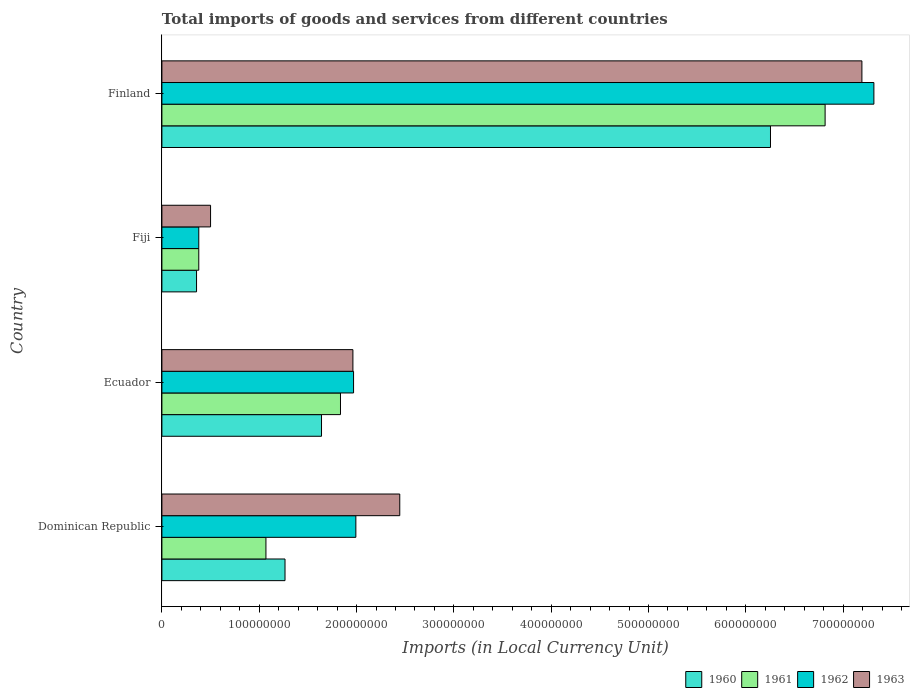How many different coloured bars are there?
Make the answer very short. 4. How many bars are there on the 1st tick from the top?
Give a very brief answer. 4. How many bars are there on the 4th tick from the bottom?
Offer a terse response. 4. What is the label of the 2nd group of bars from the top?
Give a very brief answer. Fiji. In how many cases, is the number of bars for a given country not equal to the number of legend labels?
Provide a succinct answer. 0. What is the Amount of goods and services imports in 1962 in Ecuador?
Keep it short and to the point. 1.97e+08. Across all countries, what is the maximum Amount of goods and services imports in 1963?
Your answer should be compact. 7.19e+08. Across all countries, what is the minimum Amount of goods and services imports in 1963?
Keep it short and to the point. 5.00e+07. In which country was the Amount of goods and services imports in 1961 maximum?
Your answer should be very brief. Finland. In which country was the Amount of goods and services imports in 1961 minimum?
Keep it short and to the point. Fiji. What is the total Amount of goods and services imports in 1963 in the graph?
Offer a very short reply. 1.21e+09. What is the difference between the Amount of goods and services imports in 1963 in Dominican Republic and that in Fiji?
Offer a very short reply. 1.94e+08. What is the difference between the Amount of goods and services imports in 1961 in Ecuador and the Amount of goods and services imports in 1960 in Finland?
Your response must be concise. -4.42e+08. What is the average Amount of goods and services imports in 1960 per country?
Offer a terse response. 2.38e+08. What is the difference between the Amount of goods and services imports in 1960 and Amount of goods and services imports in 1961 in Fiji?
Your response must be concise. -2.30e+06. In how many countries, is the Amount of goods and services imports in 1962 greater than 480000000 LCU?
Offer a terse response. 1. What is the ratio of the Amount of goods and services imports in 1962 in Dominican Republic to that in Finland?
Your response must be concise. 0.27. Is the Amount of goods and services imports in 1960 in Dominican Republic less than that in Fiji?
Offer a very short reply. No. What is the difference between the highest and the second highest Amount of goods and services imports in 1962?
Ensure brevity in your answer.  5.32e+08. What is the difference between the highest and the lowest Amount of goods and services imports in 1963?
Offer a terse response. 6.69e+08. In how many countries, is the Amount of goods and services imports in 1962 greater than the average Amount of goods and services imports in 1962 taken over all countries?
Keep it short and to the point. 1. What does the 4th bar from the bottom in Dominican Republic represents?
Keep it short and to the point. 1963. Are all the bars in the graph horizontal?
Keep it short and to the point. Yes. How many countries are there in the graph?
Ensure brevity in your answer.  4. Are the values on the major ticks of X-axis written in scientific E-notation?
Provide a succinct answer. No. Does the graph contain grids?
Provide a short and direct response. No. Where does the legend appear in the graph?
Your answer should be very brief. Bottom right. What is the title of the graph?
Your response must be concise. Total imports of goods and services from different countries. Does "2007" appear as one of the legend labels in the graph?
Your answer should be very brief. No. What is the label or title of the X-axis?
Provide a short and direct response. Imports (in Local Currency Unit). What is the Imports (in Local Currency Unit) of 1960 in Dominican Republic?
Your response must be concise. 1.26e+08. What is the Imports (in Local Currency Unit) in 1961 in Dominican Republic?
Provide a succinct answer. 1.07e+08. What is the Imports (in Local Currency Unit) in 1962 in Dominican Republic?
Your answer should be very brief. 1.99e+08. What is the Imports (in Local Currency Unit) in 1963 in Dominican Republic?
Provide a succinct answer. 2.44e+08. What is the Imports (in Local Currency Unit) of 1960 in Ecuador?
Your answer should be compact. 1.64e+08. What is the Imports (in Local Currency Unit) in 1961 in Ecuador?
Give a very brief answer. 1.83e+08. What is the Imports (in Local Currency Unit) in 1962 in Ecuador?
Provide a succinct answer. 1.97e+08. What is the Imports (in Local Currency Unit) of 1963 in Ecuador?
Make the answer very short. 1.96e+08. What is the Imports (in Local Currency Unit) in 1960 in Fiji?
Give a very brief answer. 3.56e+07. What is the Imports (in Local Currency Unit) of 1961 in Fiji?
Provide a succinct answer. 3.79e+07. What is the Imports (in Local Currency Unit) in 1962 in Fiji?
Make the answer very short. 3.79e+07. What is the Imports (in Local Currency Unit) of 1960 in Finland?
Your response must be concise. 6.25e+08. What is the Imports (in Local Currency Unit) in 1961 in Finland?
Give a very brief answer. 6.81e+08. What is the Imports (in Local Currency Unit) of 1962 in Finland?
Keep it short and to the point. 7.32e+08. What is the Imports (in Local Currency Unit) of 1963 in Finland?
Offer a terse response. 7.19e+08. Across all countries, what is the maximum Imports (in Local Currency Unit) in 1960?
Make the answer very short. 6.25e+08. Across all countries, what is the maximum Imports (in Local Currency Unit) in 1961?
Give a very brief answer. 6.81e+08. Across all countries, what is the maximum Imports (in Local Currency Unit) in 1962?
Your answer should be compact. 7.32e+08. Across all countries, what is the maximum Imports (in Local Currency Unit) of 1963?
Ensure brevity in your answer.  7.19e+08. Across all countries, what is the minimum Imports (in Local Currency Unit) of 1960?
Provide a short and direct response. 3.56e+07. Across all countries, what is the minimum Imports (in Local Currency Unit) in 1961?
Offer a terse response. 3.79e+07. Across all countries, what is the minimum Imports (in Local Currency Unit) in 1962?
Your answer should be very brief. 3.79e+07. What is the total Imports (in Local Currency Unit) in 1960 in the graph?
Your answer should be compact. 9.51e+08. What is the total Imports (in Local Currency Unit) in 1961 in the graph?
Offer a very short reply. 1.01e+09. What is the total Imports (in Local Currency Unit) of 1962 in the graph?
Provide a short and direct response. 1.17e+09. What is the total Imports (in Local Currency Unit) in 1963 in the graph?
Make the answer very short. 1.21e+09. What is the difference between the Imports (in Local Currency Unit) of 1960 in Dominican Republic and that in Ecuador?
Your answer should be very brief. -3.75e+07. What is the difference between the Imports (in Local Currency Unit) in 1961 in Dominican Republic and that in Ecuador?
Offer a very short reply. -7.66e+07. What is the difference between the Imports (in Local Currency Unit) of 1962 in Dominican Republic and that in Ecuador?
Your answer should be compact. 2.37e+06. What is the difference between the Imports (in Local Currency Unit) of 1963 in Dominican Republic and that in Ecuador?
Offer a terse response. 4.81e+07. What is the difference between the Imports (in Local Currency Unit) of 1960 in Dominican Republic and that in Fiji?
Keep it short and to the point. 9.09e+07. What is the difference between the Imports (in Local Currency Unit) in 1961 in Dominican Republic and that in Fiji?
Your answer should be very brief. 6.90e+07. What is the difference between the Imports (in Local Currency Unit) in 1962 in Dominican Republic and that in Fiji?
Your answer should be compact. 1.61e+08. What is the difference between the Imports (in Local Currency Unit) in 1963 in Dominican Republic and that in Fiji?
Keep it short and to the point. 1.94e+08. What is the difference between the Imports (in Local Currency Unit) of 1960 in Dominican Republic and that in Finland?
Make the answer very short. -4.99e+08. What is the difference between the Imports (in Local Currency Unit) in 1961 in Dominican Republic and that in Finland?
Offer a terse response. -5.75e+08. What is the difference between the Imports (in Local Currency Unit) in 1962 in Dominican Republic and that in Finland?
Give a very brief answer. -5.32e+08. What is the difference between the Imports (in Local Currency Unit) of 1963 in Dominican Republic and that in Finland?
Give a very brief answer. -4.75e+08. What is the difference between the Imports (in Local Currency Unit) of 1960 in Ecuador and that in Fiji?
Your response must be concise. 1.28e+08. What is the difference between the Imports (in Local Currency Unit) of 1961 in Ecuador and that in Fiji?
Ensure brevity in your answer.  1.46e+08. What is the difference between the Imports (in Local Currency Unit) of 1962 in Ecuador and that in Fiji?
Offer a terse response. 1.59e+08. What is the difference between the Imports (in Local Currency Unit) in 1963 in Ecuador and that in Fiji?
Give a very brief answer. 1.46e+08. What is the difference between the Imports (in Local Currency Unit) of 1960 in Ecuador and that in Finland?
Provide a short and direct response. -4.61e+08. What is the difference between the Imports (in Local Currency Unit) in 1961 in Ecuador and that in Finland?
Give a very brief answer. -4.98e+08. What is the difference between the Imports (in Local Currency Unit) in 1962 in Ecuador and that in Finland?
Give a very brief answer. -5.35e+08. What is the difference between the Imports (in Local Currency Unit) of 1963 in Ecuador and that in Finland?
Your answer should be very brief. -5.23e+08. What is the difference between the Imports (in Local Currency Unit) in 1960 in Fiji and that in Finland?
Provide a succinct answer. -5.90e+08. What is the difference between the Imports (in Local Currency Unit) in 1961 in Fiji and that in Finland?
Your answer should be very brief. -6.44e+08. What is the difference between the Imports (in Local Currency Unit) in 1962 in Fiji and that in Finland?
Your answer should be very brief. -6.94e+08. What is the difference between the Imports (in Local Currency Unit) in 1963 in Fiji and that in Finland?
Your response must be concise. -6.69e+08. What is the difference between the Imports (in Local Currency Unit) of 1960 in Dominican Republic and the Imports (in Local Currency Unit) of 1961 in Ecuador?
Your answer should be compact. -5.70e+07. What is the difference between the Imports (in Local Currency Unit) in 1960 in Dominican Republic and the Imports (in Local Currency Unit) in 1962 in Ecuador?
Keep it short and to the point. -7.04e+07. What is the difference between the Imports (in Local Currency Unit) in 1960 in Dominican Republic and the Imports (in Local Currency Unit) in 1963 in Ecuador?
Make the answer very short. -6.98e+07. What is the difference between the Imports (in Local Currency Unit) of 1961 in Dominican Republic and the Imports (in Local Currency Unit) of 1962 in Ecuador?
Your answer should be compact. -9.00e+07. What is the difference between the Imports (in Local Currency Unit) of 1961 in Dominican Republic and the Imports (in Local Currency Unit) of 1963 in Ecuador?
Offer a terse response. -8.94e+07. What is the difference between the Imports (in Local Currency Unit) in 1962 in Dominican Republic and the Imports (in Local Currency Unit) in 1963 in Ecuador?
Give a very brief answer. 3.04e+06. What is the difference between the Imports (in Local Currency Unit) of 1960 in Dominican Republic and the Imports (in Local Currency Unit) of 1961 in Fiji?
Ensure brevity in your answer.  8.86e+07. What is the difference between the Imports (in Local Currency Unit) of 1960 in Dominican Republic and the Imports (in Local Currency Unit) of 1962 in Fiji?
Give a very brief answer. 8.86e+07. What is the difference between the Imports (in Local Currency Unit) in 1960 in Dominican Republic and the Imports (in Local Currency Unit) in 1963 in Fiji?
Provide a short and direct response. 7.65e+07. What is the difference between the Imports (in Local Currency Unit) in 1961 in Dominican Republic and the Imports (in Local Currency Unit) in 1962 in Fiji?
Offer a very short reply. 6.90e+07. What is the difference between the Imports (in Local Currency Unit) in 1961 in Dominican Republic and the Imports (in Local Currency Unit) in 1963 in Fiji?
Give a very brief answer. 5.69e+07. What is the difference between the Imports (in Local Currency Unit) in 1962 in Dominican Republic and the Imports (in Local Currency Unit) in 1963 in Fiji?
Provide a short and direct response. 1.49e+08. What is the difference between the Imports (in Local Currency Unit) in 1960 in Dominican Republic and the Imports (in Local Currency Unit) in 1961 in Finland?
Keep it short and to the point. -5.55e+08. What is the difference between the Imports (in Local Currency Unit) in 1960 in Dominican Republic and the Imports (in Local Currency Unit) in 1962 in Finland?
Keep it short and to the point. -6.05e+08. What is the difference between the Imports (in Local Currency Unit) of 1960 in Dominican Republic and the Imports (in Local Currency Unit) of 1963 in Finland?
Give a very brief answer. -5.93e+08. What is the difference between the Imports (in Local Currency Unit) of 1961 in Dominican Republic and the Imports (in Local Currency Unit) of 1962 in Finland?
Make the answer very short. -6.25e+08. What is the difference between the Imports (in Local Currency Unit) of 1961 in Dominican Republic and the Imports (in Local Currency Unit) of 1963 in Finland?
Offer a very short reply. -6.12e+08. What is the difference between the Imports (in Local Currency Unit) of 1962 in Dominican Republic and the Imports (in Local Currency Unit) of 1963 in Finland?
Your response must be concise. -5.20e+08. What is the difference between the Imports (in Local Currency Unit) of 1960 in Ecuador and the Imports (in Local Currency Unit) of 1961 in Fiji?
Keep it short and to the point. 1.26e+08. What is the difference between the Imports (in Local Currency Unit) of 1960 in Ecuador and the Imports (in Local Currency Unit) of 1962 in Fiji?
Give a very brief answer. 1.26e+08. What is the difference between the Imports (in Local Currency Unit) in 1960 in Ecuador and the Imports (in Local Currency Unit) in 1963 in Fiji?
Offer a terse response. 1.14e+08. What is the difference between the Imports (in Local Currency Unit) in 1961 in Ecuador and the Imports (in Local Currency Unit) in 1962 in Fiji?
Your answer should be very brief. 1.46e+08. What is the difference between the Imports (in Local Currency Unit) of 1961 in Ecuador and the Imports (in Local Currency Unit) of 1963 in Fiji?
Ensure brevity in your answer.  1.33e+08. What is the difference between the Imports (in Local Currency Unit) in 1962 in Ecuador and the Imports (in Local Currency Unit) in 1963 in Fiji?
Ensure brevity in your answer.  1.47e+08. What is the difference between the Imports (in Local Currency Unit) of 1960 in Ecuador and the Imports (in Local Currency Unit) of 1961 in Finland?
Provide a succinct answer. -5.17e+08. What is the difference between the Imports (in Local Currency Unit) of 1960 in Ecuador and the Imports (in Local Currency Unit) of 1962 in Finland?
Provide a succinct answer. -5.68e+08. What is the difference between the Imports (in Local Currency Unit) of 1960 in Ecuador and the Imports (in Local Currency Unit) of 1963 in Finland?
Keep it short and to the point. -5.55e+08. What is the difference between the Imports (in Local Currency Unit) of 1961 in Ecuador and the Imports (in Local Currency Unit) of 1962 in Finland?
Offer a terse response. -5.48e+08. What is the difference between the Imports (in Local Currency Unit) of 1961 in Ecuador and the Imports (in Local Currency Unit) of 1963 in Finland?
Your answer should be compact. -5.36e+08. What is the difference between the Imports (in Local Currency Unit) in 1962 in Ecuador and the Imports (in Local Currency Unit) in 1963 in Finland?
Ensure brevity in your answer.  -5.22e+08. What is the difference between the Imports (in Local Currency Unit) of 1960 in Fiji and the Imports (in Local Currency Unit) of 1961 in Finland?
Keep it short and to the point. -6.46e+08. What is the difference between the Imports (in Local Currency Unit) of 1960 in Fiji and the Imports (in Local Currency Unit) of 1962 in Finland?
Your answer should be compact. -6.96e+08. What is the difference between the Imports (in Local Currency Unit) in 1960 in Fiji and the Imports (in Local Currency Unit) in 1963 in Finland?
Your response must be concise. -6.84e+08. What is the difference between the Imports (in Local Currency Unit) in 1961 in Fiji and the Imports (in Local Currency Unit) in 1962 in Finland?
Provide a succinct answer. -6.94e+08. What is the difference between the Imports (in Local Currency Unit) of 1961 in Fiji and the Imports (in Local Currency Unit) of 1963 in Finland?
Offer a terse response. -6.81e+08. What is the difference between the Imports (in Local Currency Unit) in 1962 in Fiji and the Imports (in Local Currency Unit) in 1963 in Finland?
Your answer should be very brief. -6.81e+08. What is the average Imports (in Local Currency Unit) of 1960 per country?
Provide a short and direct response. 2.38e+08. What is the average Imports (in Local Currency Unit) of 1961 per country?
Your answer should be compact. 2.52e+08. What is the average Imports (in Local Currency Unit) in 1962 per country?
Offer a terse response. 2.91e+08. What is the average Imports (in Local Currency Unit) of 1963 per country?
Keep it short and to the point. 3.02e+08. What is the difference between the Imports (in Local Currency Unit) of 1960 and Imports (in Local Currency Unit) of 1961 in Dominican Republic?
Your response must be concise. 1.96e+07. What is the difference between the Imports (in Local Currency Unit) of 1960 and Imports (in Local Currency Unit) of 1962 in Dominican Republic?
Your response must be concise. -7.28e+07. What is the difference between the Imports (in Local Currency Unit) in 1960 and Imports (in Local Currency Unit) in 1963 in Dominican Republic?
Provide a short and direct response. -1.18e+08. What is the difference between the Imports (in Local Currency Unit) of 1961 and Imports (in Local Currency Unit) of 1962 in Dominican Republic?
Ensure brevity in your answer.  -9.24e+07. What is the difference between the Imports (in Local Currency Unit) of 1961 and Imports (in Local Currency Unit) of 1963 in Dominican Republic?
Keep it short and to the point. -1.38e+08. What is the difference between the Imports (in Local Currency Unit) of 1962 and Imports (in Local Currency Unit) of 1963 in Dominican Republic?
Offer a terse response. -4.51e+07. What is the difference between the Imports (in Local Currency Unit) of 1960 and Imports (in Local Currency Unit) of 1961 in Ecuador?
Ensure brevity in your answer.  -1.95e+07. What is the difference between the Imports (in Local Currency Unit) of 1960 and Imports (in Local Currency Unit) of 1962 in Ecuador?
Provide a succinct answer. -3.29e+07. What is the difference between the Imports (in Local Currency Unit) in 1960 and Imports (in Local Currency Unit) in 1963 in Ecuador?
Keep it short and to the point. -3.23e+07. What is the difference between the Imports (in Local Currency Unit) of 1961 and Imports (in Local Currency Unit) of 1962 in Ecuador?
Offer a very short reply. -1.34e+07. What is the difference between the Imports (in Local Currency Unit) of 1961 and Imports (in Local Currency Unit) of 1963 in Ecuador?
Keep it short and to the point. -1.28e+07. What is the difference between the Imports (in Local Currency Unit) in 1962 and Imports (in Local Currency Unit) in 1963 in Ecuador?
Offer a very short reply. 6.72e+05. What is the difference between the Imports (in Local Currency Unit) of 1960 and Imports (in Local Currency Unit) of 1961 in Fiji?
Make the answer very short. -2.30e+06. What is the difference between the Imports (in Local Currency Unit) of 1960 and Imports (in Local Currency Unit) of 1962 in Fiji?
Make the answer very short. -2.30e+06. What is the difference between the Imports (in Local Currency Unit) in 1960 and Imports (in Local Currency Unit) in 1963 in Fiji?
Offer a very short reply. -1.44e+07. What is the difference between the Imports (in Local Currency Unit) of 1961 and Imports (in Local Currency Unit) of 1962 in Fiji?
Offer a very short reply. 0. What is the difference between the Imports (in Local Currency Unit) in 1961 and Imports (in Local Currency Unit) in 1963 in Fiji?
Your response must be concise. -1.21e+07. What is the difference between the Imports (in Local Currency Unit) of 1962 and Imports (in Local Currency Unit) of 1963 in Fiji?
Make the answer very short. -1.21e+07. What is the difference between the Imports (in Local Currency Unit) in 1960 and Imports (in Local Currency Unit) in 1961 in Finland?
Offer a very short reply. -5.61e+07. What is the difference between the Imports (in Local Currency Unit) of 1960 and Imports (in Local Currency Unit) of 1962 in Finland?
Offer a very short reply. -1.06e+08. What is the difference between the Imports (in Local Currency Unit) of 1960 and Imports (in Local Currency Unit) of 1963 in Finland?
Your answer should be compact. -9.39e+07. What is the difference between the Imports (in Local Currency Unit) of 1961 and Imports (in Local Currency Unit) of 1962 in Finland?
Your answer should be very brief. -5.01e+07. What is the difference between the Imports (in Local Currency Unit) of 1961 and Imports (in Local Currency Unit) of 1963 in Finland?
Offer a very short reply. -3.78e+07. What is the difference between the Imports (in Local Currency Unit) of 1962 and Imports (in Local Currency Unit) of 1963 in Finland?
Offer a very short reply. 1.23e+07. What is the ratio of the Imports (in Local Currency Unit) of 1960 in Dominican Republic to that in Ecuador?
Give a very brief answer. 0.77. What is the ratio of the Imports (in Local Currency Unit) in 1961 in Dominican Republic to that in Ecuador?
Make the answer very short. 0.58. What is the ratio of the Imports (in Local Currency Unit) of 1962 in Dominican Republic to that in Ecuador?
Offer a very short reply. 1.01. What is the ratio of the Imports (in Local Currency Unit) in 1963 in Dominican Republic to that in Ecuador?
Provide a succinct answer. 1.25. What is the ratio of the Imports (in Local Currency Unit) of 1960 in Dominican Republic to that in Fiji?
Offer a terse response. 3.55. What is the ratio of the Imports (in Local Currency Unit) in 1961 in Dominican Republic to that in Fiji?
Give a very brief answer. 2.82. What is the ratio of the Imports (in Local Currency Unit) of 1962 in Dominican Republic to that in Fiji?
Provide a short and direct response. 5.26. What is the ratio of the Imports (in Local Currency Unit) of 1963 in Dominican Republic to that in Fiji?
Provide a short and direct response. 4.89. What is the ratio of the Imports (in Local Currency Unit) in 1960 in Dominican Republic to that in Finland?
Provide a short and direct response. 0.2. What is the ratio of the Imports (in Local Currency Unit) of 1961 in Dominican Republic to that in Finland?
Provide a succinct answer. 0.16. What is the ratio of the Imports (in Local Currency Unit) of 1962 in Dominican Republic to that in Finland?
Your response must be concise. 0.27. What is the ratio of the Imports (in Local Currency Unit) of 1963 in Dominican Republic to that in Finland?
Give a very brief answer. 0.34. What is the ratio of the Imports (in Local Currency Unit) in 1960 in Ecuador to that in Fiji?
Provide a short and direct response. 4.61. What is the ratio of the Imports (in Local Currency Unit) of 1961 in Ecuador to that in Fiji?
Keep it short and to the point. 4.84. What is the ratio of the Imports (in Local Currency Unit) of 1962 in Ecuador to that in Fiji?
Offer a very short reply. 5.2. What is the ratio of the Imports (in Local Currency Unit) of 1963 in Ecuador to that in Fiji?
Provide a short and direct response. 3.93. What is the ratio of the Imports (in Local Currency Unit) in 1960 in Ecuador to that in Finland?
Provide a short and direct response. 0.26. What is the ratio of the Imports (in Local Currency Unit) in 1961 in Ecuador to that in Finland?
Give a very brief answer. 0.27. What is the ratio of the Imports (in Local Currency Unit) of 1962 in Ecuador to that in Finland?
Your response must be concise. 0.27. What is the ratio of the Imports (in Local Currency Unit) of 1963 in Ecuador to that in Finland?
Provide a succinct answer. 0.27. What is the ratio of the Imports (in Local Currency Unit) in 1960 in Fiji to that in Finland?
Your response must be concise. 0.06. What is the ratio of the Imports (in Local Currency Unit) of 1961 in Fiji to that in Finland?
Keep it short and to the point. 0.06. What is the ratio of the Imports (in Local Currency Unit) in 1962 in Fiji to that in Finland?
Make the answer very short. 0.05. What is the ratio of the Imports (in Local Currency Unit) of 1963 in Fiji to that in Finland?
Your answer should be very brief. 0.07. What is the difference between the highest and the second highest Imports (in Local Currency Unit) in 1960?
Offer a terse response. 4.61e+08. What is the difference between the highest and the second highest Imports (in Local Currency Unit) of 1961?
Give a very brief answer. 4.98e+08. What is the difference between the highest and the second highest Imports (in Local Currency Unit) of 1962?
Provide a short and direct response. 5.32e+08. What is the difference between the highest and the second highest Imports (in Local Currency Unit) in 1963?
Provide a succinct answer. 4.75e+08. What is the difference between the highest and the lowest Imports (in Local Currency Unit) of 1960?
Provide a succinct answer. 5.90e+08. What is the difference between the highest and the lowest Imports (in Local Currency Unit) of 1961?
Keep it short and to the point. 6.44e+08. What is the difference between the highest and the lowest Imports (in Local Currency Unit) of 1962?
Offer a very short reply. 6.94e+08. What is the difference between the highest and the lowest Imports (in Local Currency Unit) in 1963?
Keep it short and to the point. 6.69e+08. 